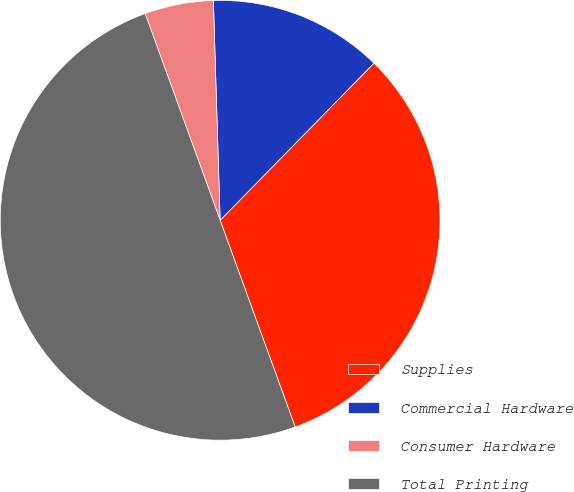Convert chart to OTSL. <chart><loc_0><loc_0><loc_500><loc_500><pie_chart><fcel>Supplies<fcel>Commercial Hardware<fcel>Consumer Hardware<fcel>Total Printing<nl><fcel>32.13%<fcel>12.82%<fcel>5.05%<fcel>50.0%<nl></chart> 